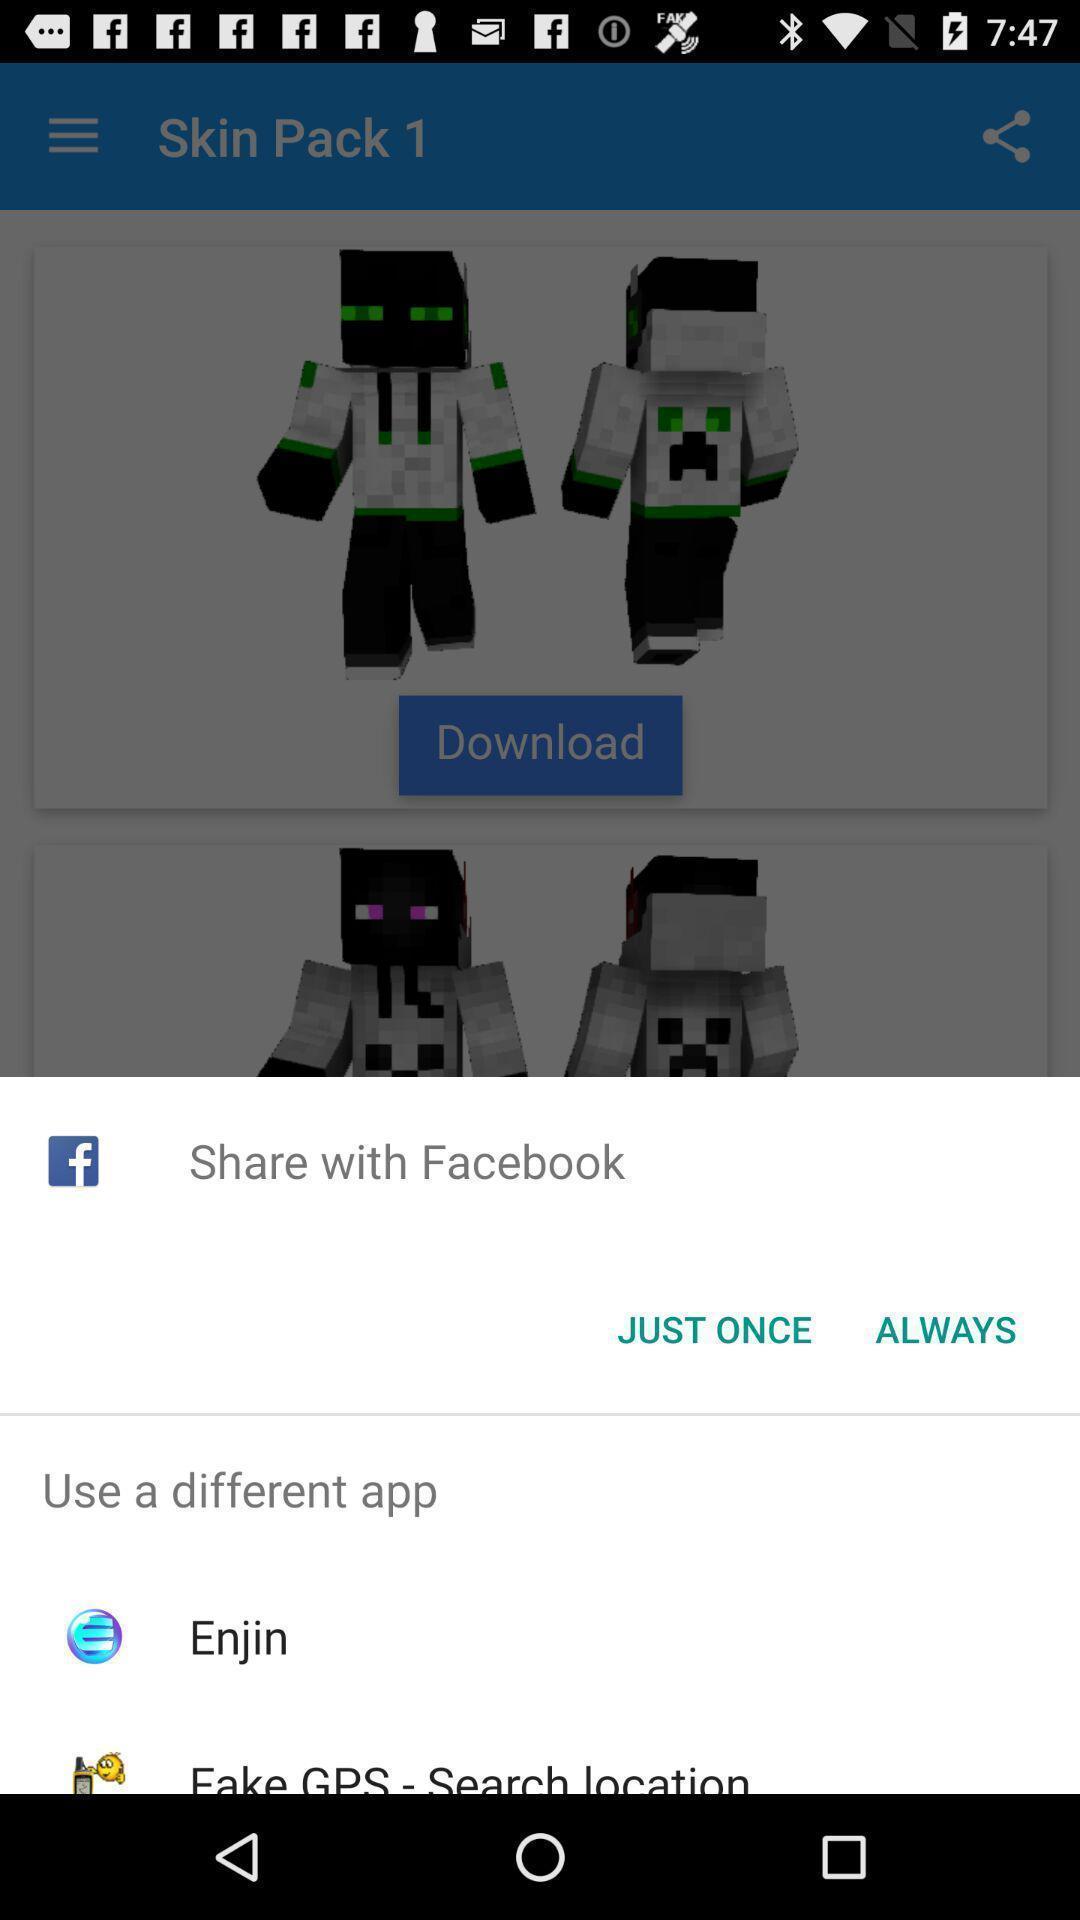Tell me about the visual elements in this screen capture. Popup showing few options. 